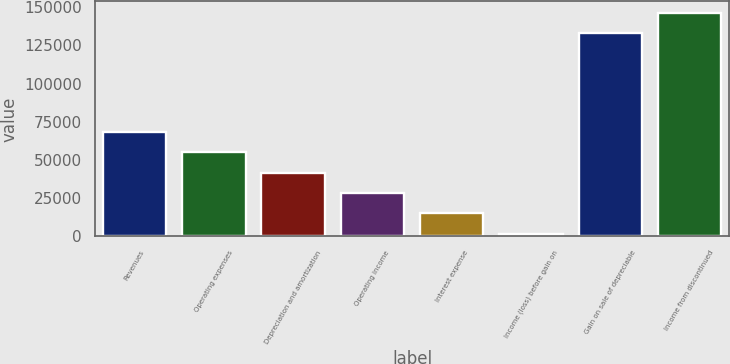Convert chart to OTSL. <chart><loc_0><loc_0><loc_500><loc_500><bar_chart><fcel>Revenues<fcel>Operating expenses<fcel>Depreciation and amortization<fcel>Operating income<fcel>Interest expense<fcel>Income (loss) before gain on<fcel>Gain on sale of depreciable<fcel>Income from discontinued<nl><fcel>68382<fcel>55057.8<fcel>41733.6<fcel>28409.4<fcel>15085.2<fcel>1761<fcel>133242<fcel>146566<nl></chart> 